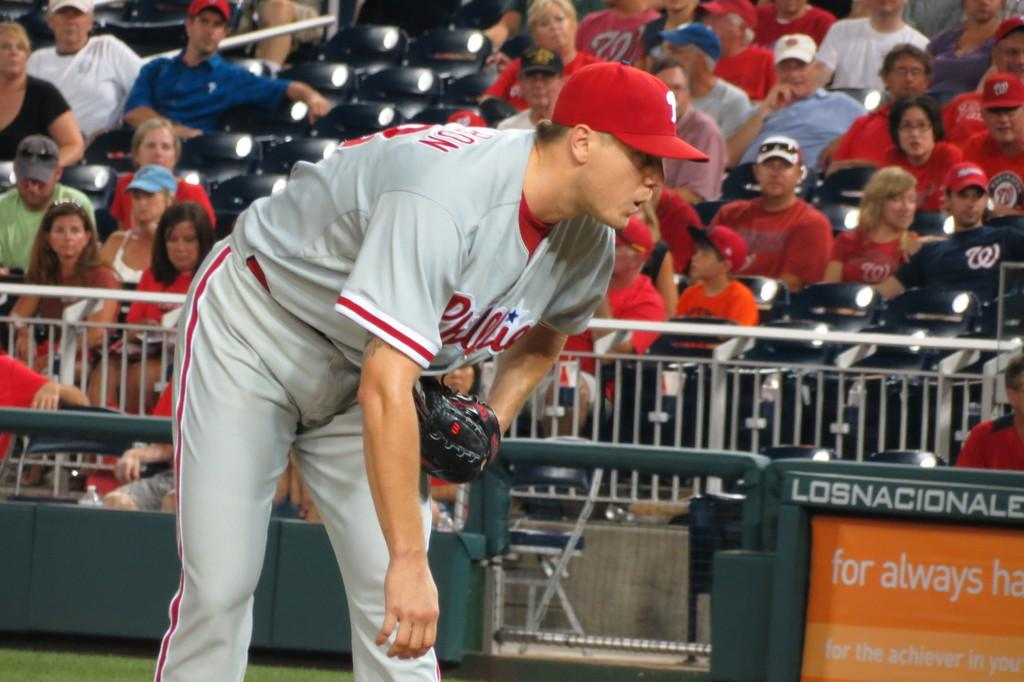<image>
Write a terse but informative summary of the picture. the word Phillies is on the jersey of a person 